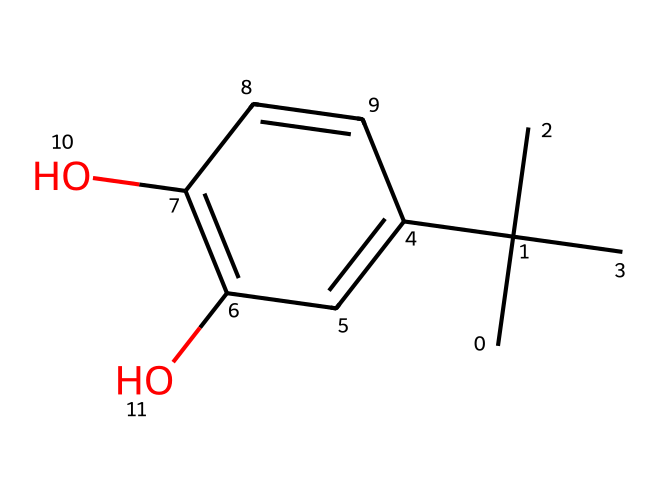How many carbon atoms are in tert-butylhydroquinone? By analyzing the SMILES representation, we can count the carbon atoms. The tert-butyl group (CC(C)(C)) contributes four carbons, and the aromatic ring (C1=CC(=C(C=C1))) contributes another four carbons, totaling eight.
Answer: eight What functional groups are present in tert-butylhydroquinone? The SMILES structure shows two hydroxyl groups (–OH), which are evident in the 'O' parts of the aromatic ring structure. These make it a dihydroxy compound.
Answer: dihydroxy How many hydrogen atoms are in tert-butylhydroquinone? By counting the hydrogen atoms attached to each carbon in the structure, considering the tetravalency of carbon and the oxygen atoms' bonding, we find there are ten hydrogen atoms connected to the carbon framework of the molecule.
Answer: ten What type of antioxidant is tert-butylhydroquinone categorized as? tert-Butylhydroquinone is categorized as a synthetic antioxidant, which means it is manufactured and added to foods for preservation. Its structure indicates it can donate electrons, preventing oxidation.
Answer: synthetic antioxidant What role does the tert-butyl group play in tert-butylhydroquinone's functionality? The tert-butyl group enhances the lipophilicity of the compound, allowing it to integrate better into lipid-containing food matrices, improving its effectiveness as a preservative against oxidation.
Answer: enhances lipophilicity What is the total number of rings present in tert-butylhydroquinone? The aromatic portion of the molecule indicates the presence of one cyclohexene ring. There are no other rings present, making the total count one ring.
Answer: one 